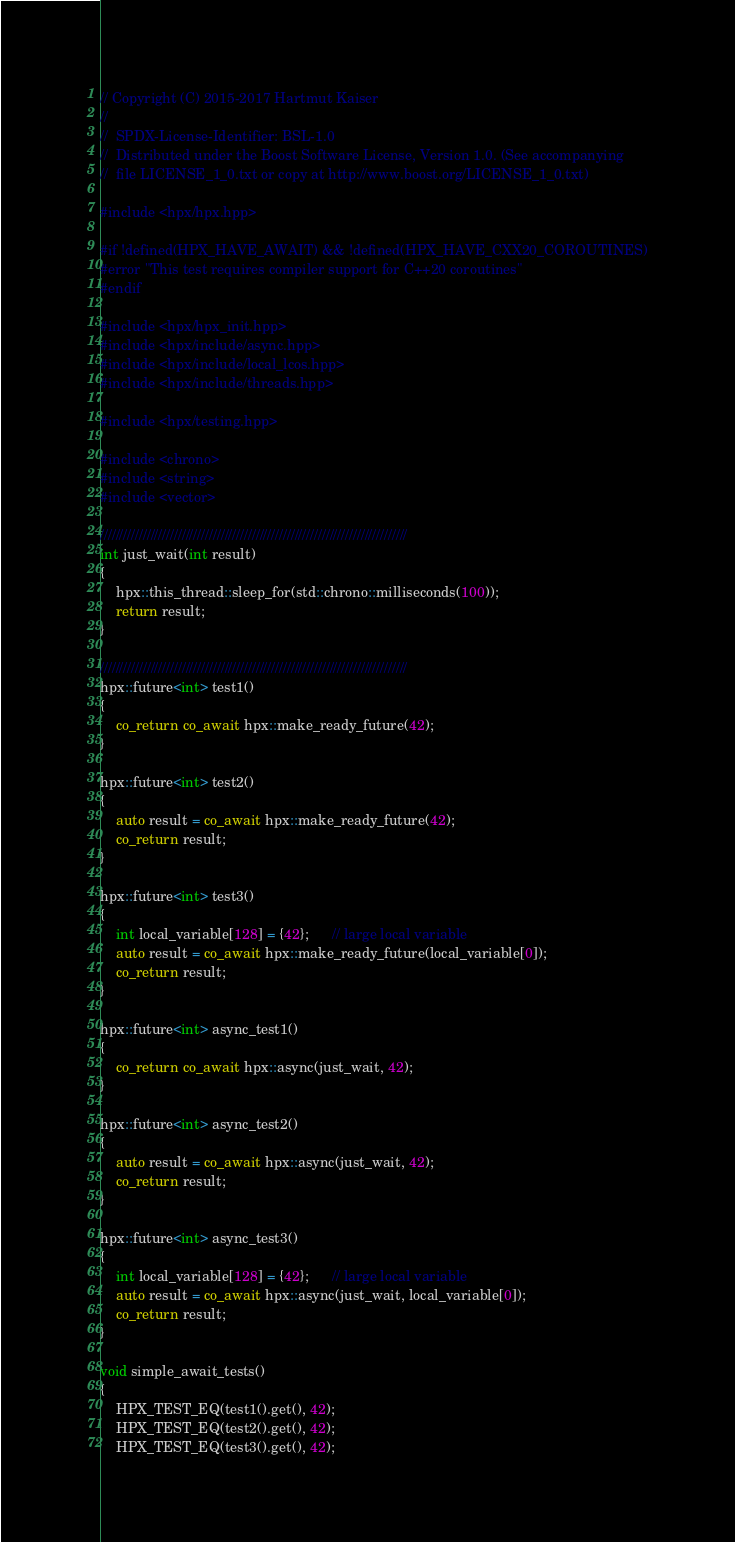Convert code to text. <code><loc_0><loc_0><loc_500><loc_500><_C++_>// Copyright (C) 2015-2017 Hartmut Kaiser
//
//  SPDX-License-Identifier: BSL-1.0
//  Distributed under the Boost Software License, Version 1.0. (See accompanying
//  file LICENSE_1_0.txt or copy at http://www.boost.org/LICENSE_1_0.txt)

#include <hpx/hpx.hpp>

#if !defined(HPX_HAVE_AWAIT) && !defined(HPX_HAVE_CXX20_COROUTINES)
#error "This test requires compiler support for C++20 coroutines"
#endif

#include <hpx/hpx_init.hpp>
#include <hpx/include/async.hpp>
#include <hpx/include/local_lcos.hpp>
#include <hpx/include/threads.hpp>

#include <hpx/testing.hpp>

#include <chrono>
#include <string>
#include <vector>

///////////////////////////////////////////////////////////////////////////////
int just_wait(int result)
{
    hpx::this_thread::sleep_for(std::chrono::milliseconds(100));
    return result;
}

///////////////////////////////////////////////////////////////////////////////
hpx::future<int> test1()
{
    co_return co_await hpx::make_ready_future(42);
}

hpx::future<int> test2()
{
    auto result = co_await hpx::make_ready_future(42);
    co_return result;
}

hpx::future<int> test3()
{
    int local_variable[128] = {42};      // large local variable
    auto result = co_await hpx::make_ready_future(local_variable[0]);
    co_return result;
}

hpx::future<int> async_test1()
{
    co_return co_await hpx::async(just_wait, 42);
}

hpx::future<int> async_test2()
{
    auto result = co_await hpx::async(just_wait, 42);
    co_return result;
}

hpx::future<int> async_test3()
{
    int local_variable[128] = {42};      // large local variable
    auto result = co_await hpx::async(just_wait, local_variable[0]);
    co_return result;
}

void simple_await_tests()
{
    HPX_TEST_EQ(test1().get(), 42);
    HPX_TEST_EQ(test2().get(), 42);
    HPX_TEST_EQ(test3().get(), 42);
</code> 